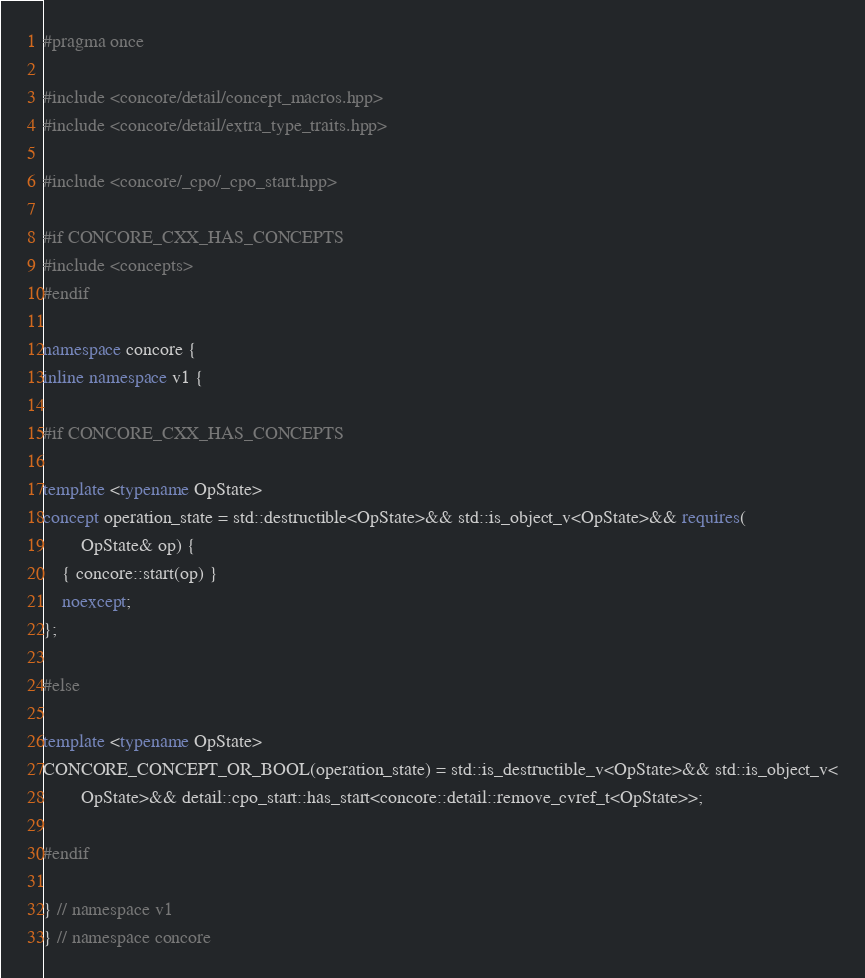Convert code to text. <code><loc_0><loc_0><loc_500><loc_500><_C++_>#pragma once

#include <concore/detail/concept_macros.hpp>
#include <concore/detail/extra_type_traits.hpp>

#include <concore/_cpo/_cpo_start.hpp>

#if CONCORE_CXX_HAS_CONCEPTS
#include <concepts>
#endif

namespace concore {
inline namespace v1 {

#if CONCORE_CXX_HAS_CONCEPTS

template <typename OpState>
concept operation_state = std::destructible<OpState>&& std::is_object_v<OpState>&& requires(
        OpState& op) {
    { concore::start(op) }
    noexcept;
};

#else

template <typename OpState>
CONCORE_CONCEPT_OR_BOOL(operation_state) = std::is_destructible_v<OpState>&& std::is_object_v<
        OpState>&& detail::cpo_start::has_start<concore::detail::remove_cvref_t<OpState>>;

#endif

} // namespace v1
} // namespace concore
</code> 